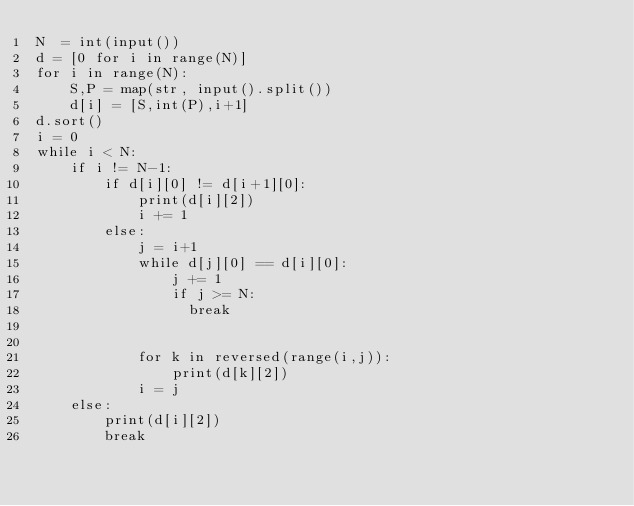Convert code to text. <code><loc_0><loc_0><loc_500><loc_500><_Python_>N  = int(input())
d = [0 for i in range(N)]
for i in range(N):
    S,P = map(str, input().split())
    d[i] = [S,int(P),i+1]
d.sort()
i = 0
while i < N:
    if i != N-1:
        if d[i][0] != d[i+1][0]:
            print(d[i][2])
            i += 1
        else:
            j = i+1
            while d[j][0] == d[i][0]:
                j += 1
                if j >= N:
                  break
                
                
            for k in reversed(range(i,j)):
                print(d[k][2])
            i = j
    else:
        print(d[i][2])
        break</code> 